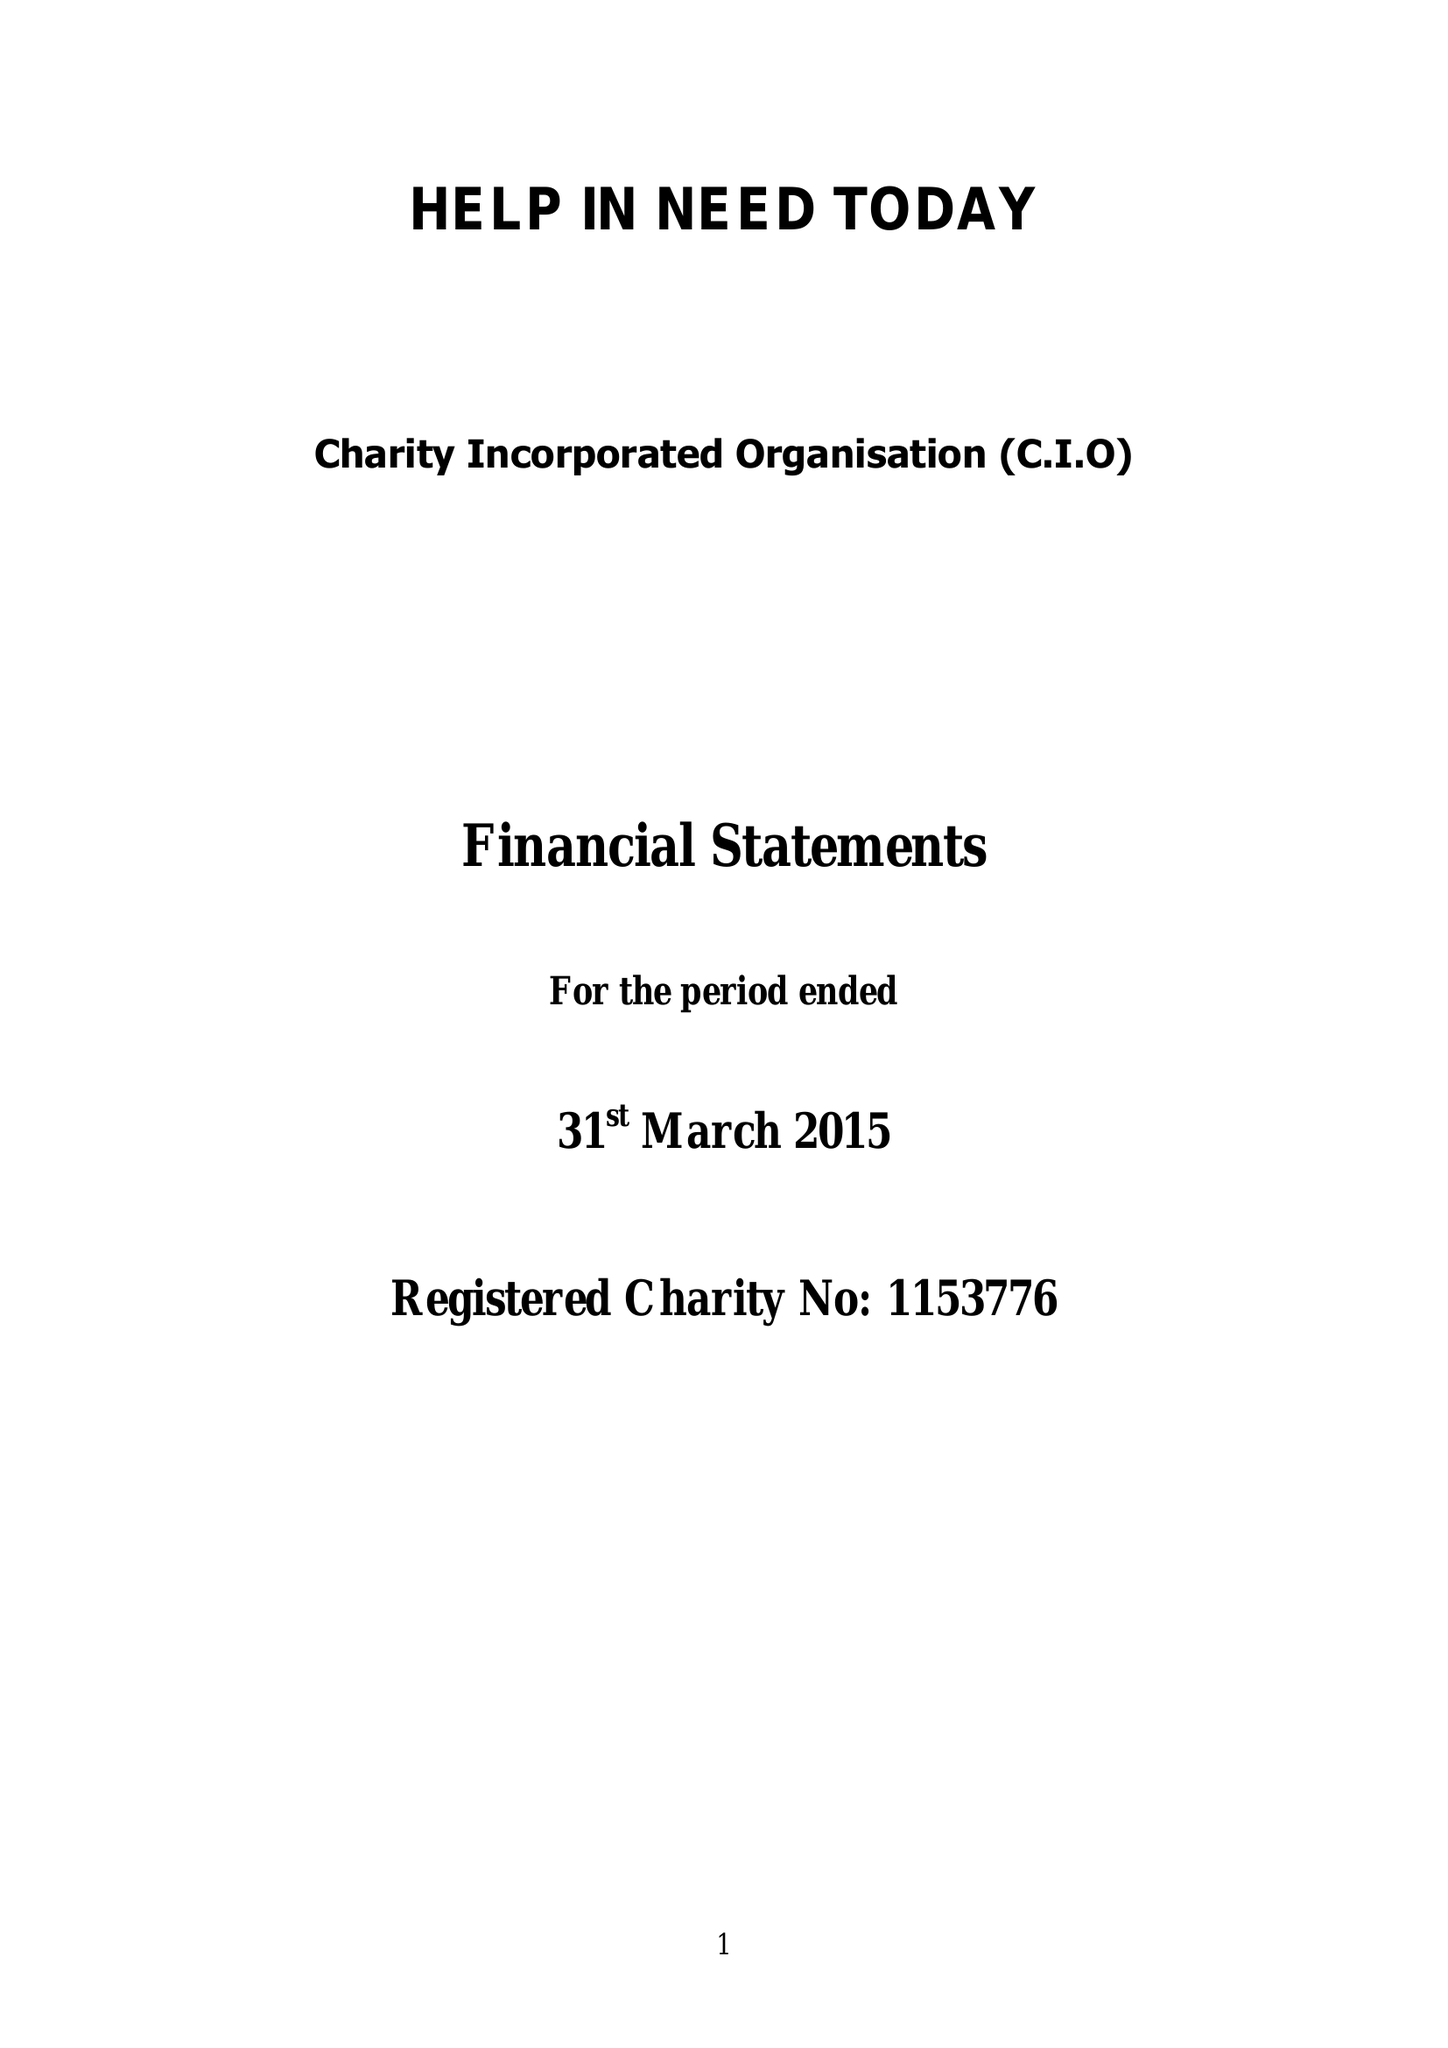What is the value for the address__post_town?
Answer the question using a single word or phrase. LONDON 